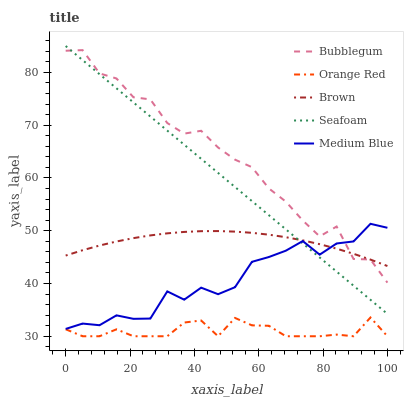Does Orange Red have the minimum area under the curve?
Answer yes or no. Yes. Does Bubblegum have the maximum area under the curve?
Answer yes or no. Yes. Does Medium Blue have the minimum area under the curve?
Answer yes or no. No. Does Medium Blue have the maximum area under the curve?
Answer yes or no. No. Is Seafoam the smoothest?
Answer yes or no. Yes. Is Bubblegum the roughest?
Answer yes or no. Yes. Is Medium Blue the smoothest?
Answer yes or no. No. Is Medium Blue the roughest?
Answer yes or no. No. Does Orange Red have the lowest value?
Answer yes or no. Yes. Does Medium Blue have the lowest value?
Answer yes or no. No. Does Seafoam have the highest value?
Answer yes or no. Yes. Does Medium Blue have the highest value?
Answer yes or no. No. Is Orange Red less than Brown?
Answer yes or no. Yes. Is Brown greater than Orange Red?
Answer yes or no. Yes. Does Brown intersect Bubblegum?
Answer yes or no. Yes. Is Brown less than Bubblegum?
Answer yes or no. No. Is Brown greater than Bubblegum?
Answer yes or no. No. Does Orange Red intersect Brown?
Answer yes or no. No. 